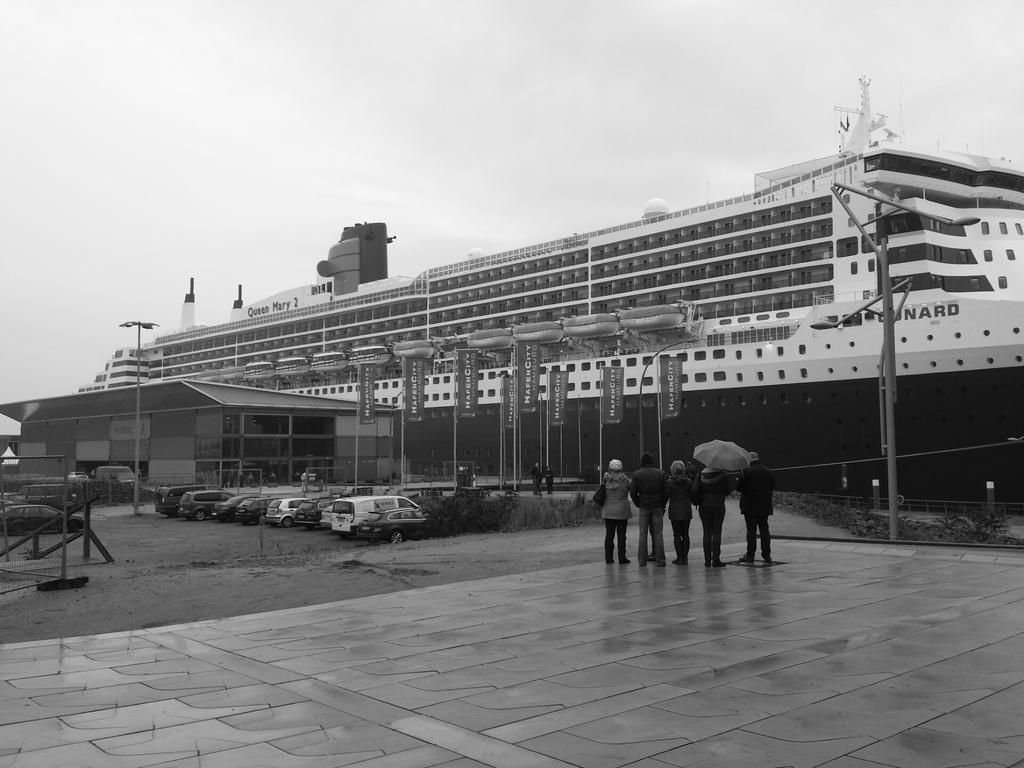How would you summarize this image in a sentence or two? In this image there are a few people standing and there are a few vehicles parked in front of the building, there are poles, banners and railing, behind that there is a huge ship on the river. In the background there is the sky. 